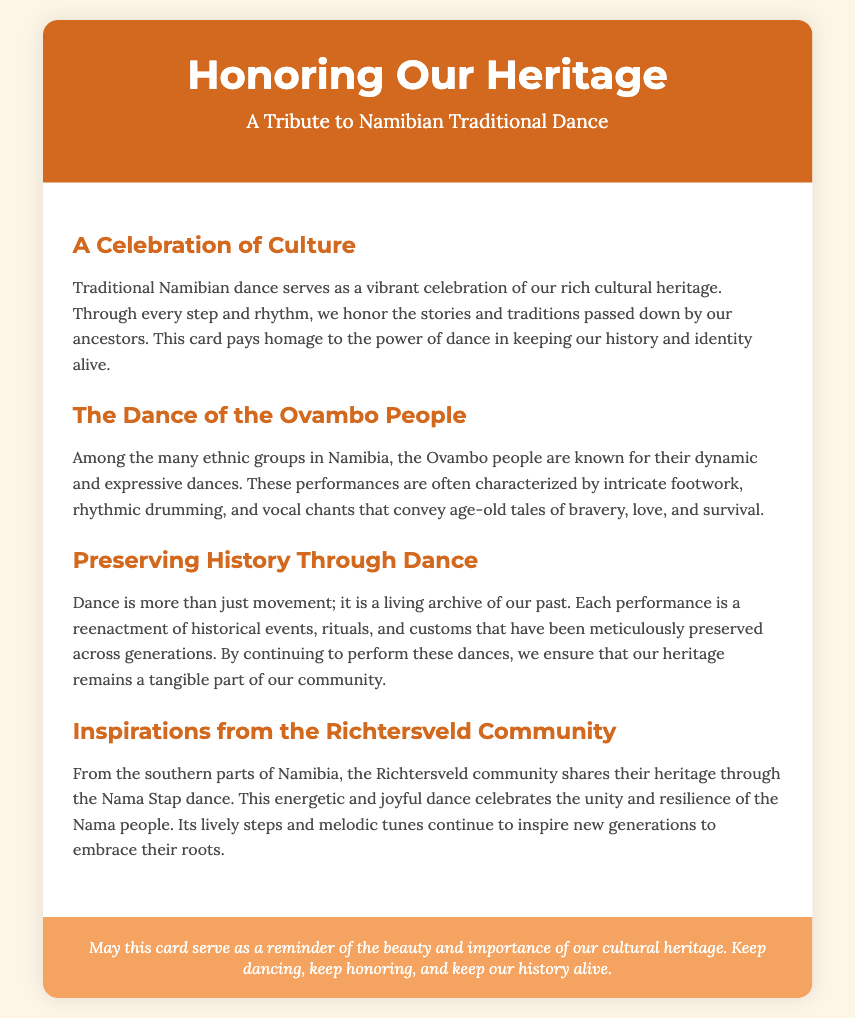what is the title of the card? The title of the card is found in the header section of the document.
Answer: Honoring Our Heritage who are the Ovambo people? The Ovambo people are mentioned in a section discussing traditional dances in Namibia.
Answer: An ethnic group in Namibia what dance is celebrated by the Richtersveld community? The specific dance celebrated by the Richtersveld community is highlighted in the respective section.
Answer: Nama Stap dance what is the significance of dance according to the document? The document explains that dance serves as a living archive and preserves history through performances.
Answer: A living archive of our past how is the dance characterized among the Ovambo people? The characteristics of Ovambo dance are detailed in a section discussing their traditional performances.
Answer: Intricate footwork, rhythmic drumming, and vocal chants what does the card serve as a reminder of? The footer provides a summary of the card's purpose.
Answer: The beauty and importance of our cultural heritage 